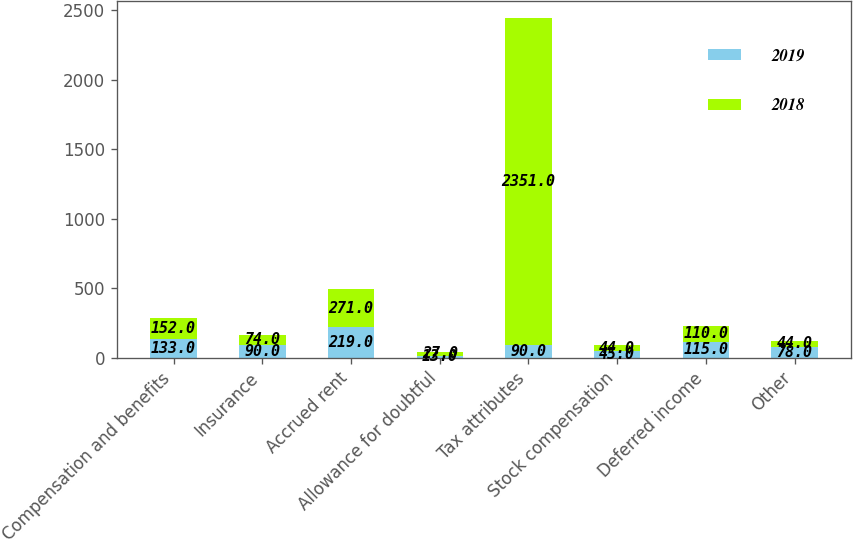Convert chart to OTSL. <chart><loc_0><loc_0><loc_500><loc_500><stacked_bar_chart><ecel><fcel>Compensation and benefits<fcel>Insurance<fcel>Accrued rent<fcel>Allowance for doubtful<fcel>Tax attributes<fcel>Stock compensation<fcel>Deferred income<fcel>Other<nl><fcel>2019<fcel>133<fcel>90<fcel>219<fcel>13<fcel>90<fcel>45<fcel>115<fcel>78<nl><fcel>2018<fcel>152<fcel>74<fcel>271<fcel>27<fcel>2351<fcel>44<fcel>110<fcel>44<nl></chart> 